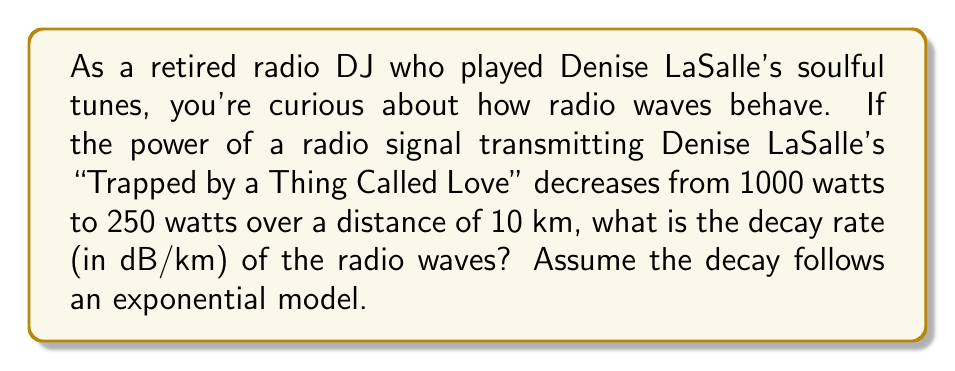Help me with this question. Let's approach this step-by-step:

1) The exponential decay model for radio wave power is given by:

   $$P(d) = P_0 e^{-\alpha d}$$

   Where $P(d)$ is the power at distance $d$, $P_0$ is the initial power, and $\alpha$ is the decay constant.

2) We're given:
   $P_0 = 1000$ watts
   $P(10) = 250$ watts
   $d = 10$ km

3) Substituting these values into the equation:

   $$250 = 1000 e^{-10\alpha}$$

4) Dividing both sides by 1000:

   $$0.25 = e^{-10\alpha}$$

5) Taking the natural log of both sides:

   $$\ln(0.25) = -10\alpha$$

6) Solving for $\alpha$:

   $$\alpha = -\frac{\ln(0.25)}{10} = 0.1386 \text{ km}^{-1}$$

7) To convert this to dB/km, we use the relation:

   $$\text{Decay rate (dB/km)} = 10 \log_{10}(e) \cdot \alpha$$

8) Substituting our value for $\alpha$:

   $$\text{Decay rate} = 10 \log_{10}(e) \cdot 0.1386 = 6.02 \text{ dB/km}$$
Answer: 6.02 dB/km 